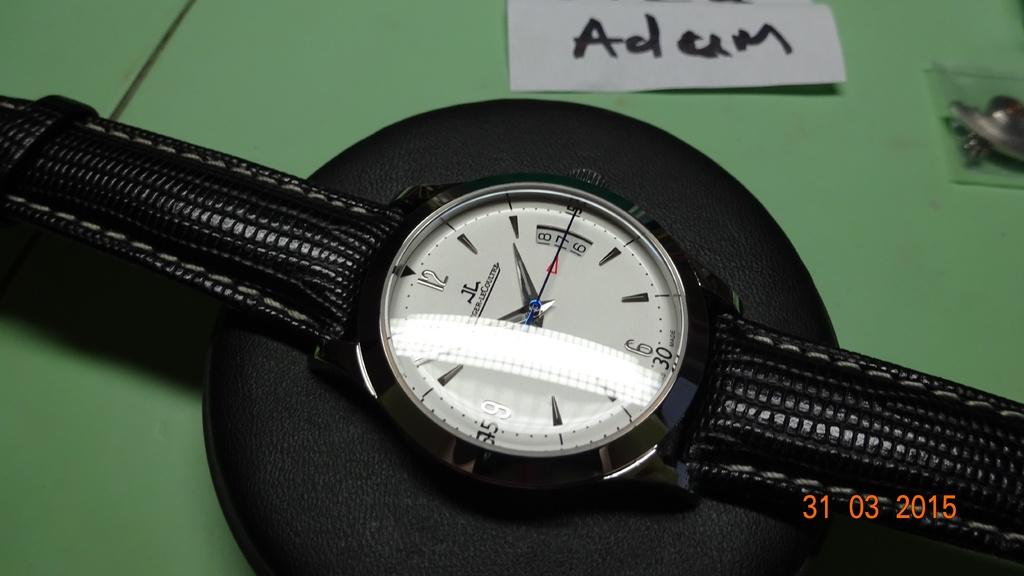What object can be seen in the image? There is a watch in the image. Where is the watch located? The watch is placed on a table. What type of crack is visible on the watch in the image? There is no crack visible on the watch in the image. Is the watch made of ice in the image? No, the watch is not made of ice in the image. Can you see any crayons near the watch in the image? There are no crayons present in the image. 